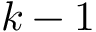<formula> <loc_0><loc_0><loc_500><loc_500>k - 1</formula> 